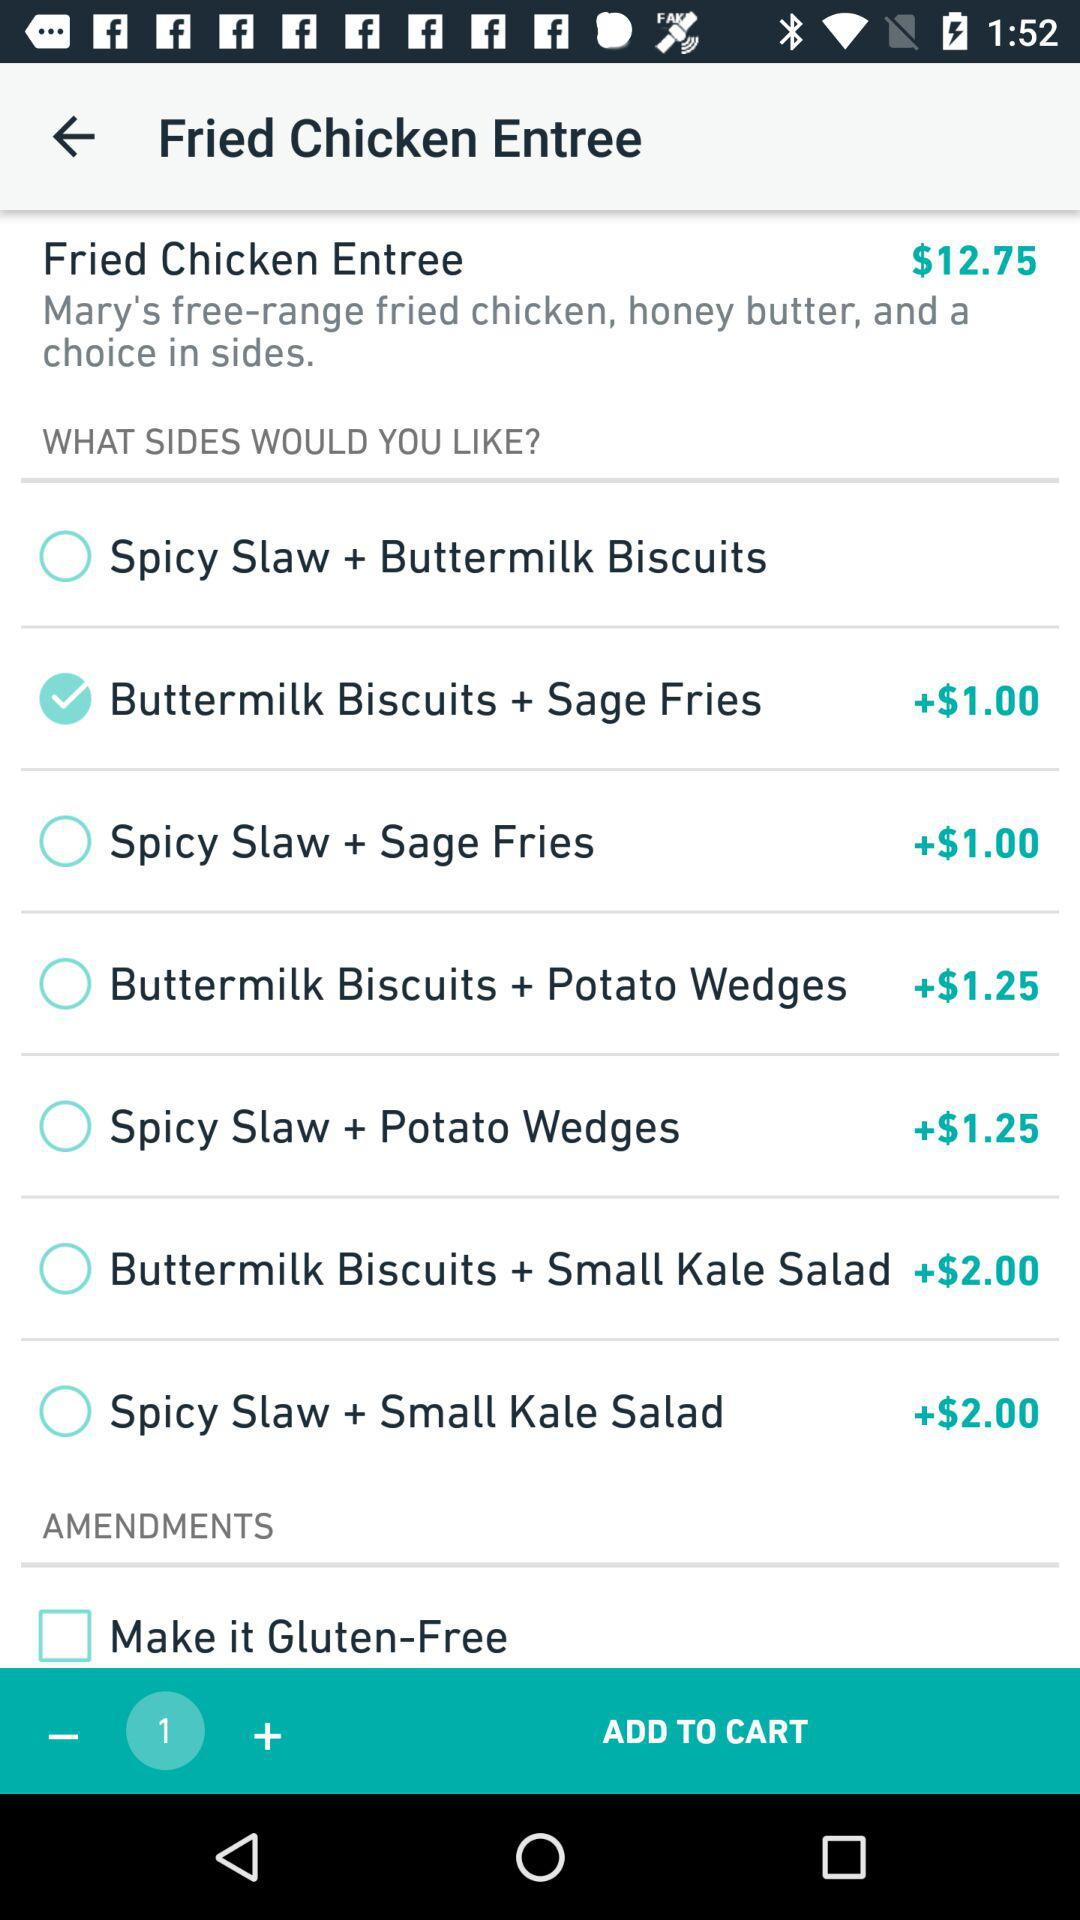Which extra sides are added to the "Fried Chicken Entree"? The extra side that is added to the "Fried Chicken Entree" is "Buttermilk Biscuits + Sage Fries". 